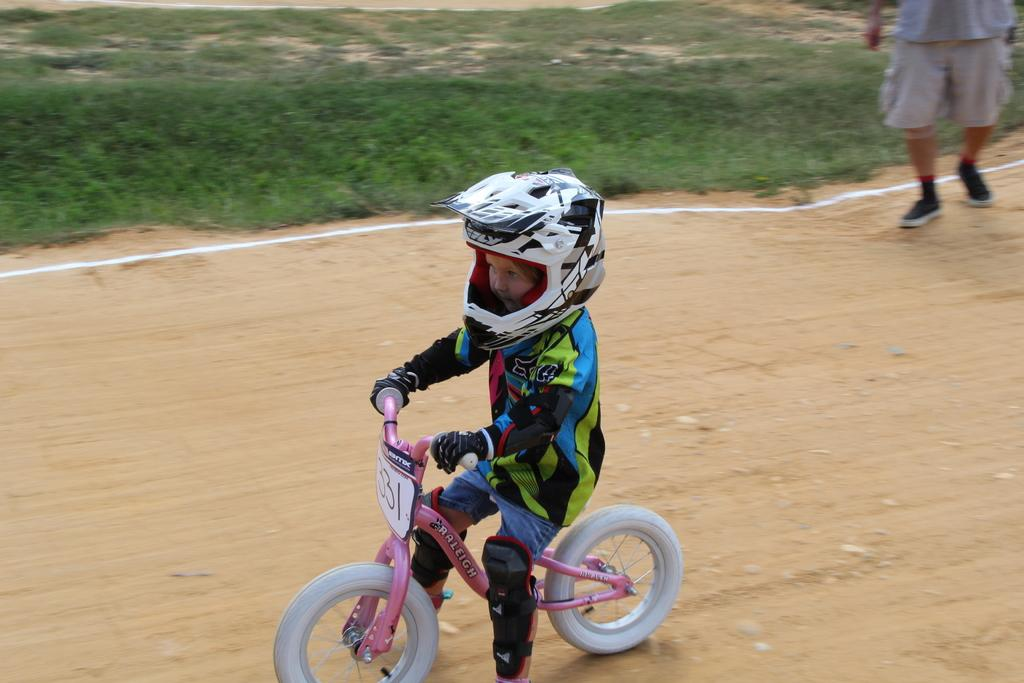Who is the main subject in the image? The main subject in the image is a child. What is the child doing in the image? The child is sitting on a bicycle. Is the child wearing any safety gear in the image? Yes, the child is wearing a helmet in the image. Where is the child located in the image? The child is on the road in the image. Can you describe the person on the ground in the image? There is a person on the ground in the image, but their actions or role cannot be determined from the provided facts. What type of authority figure is present in the image? There is no authority figure present in the image. How does the child receive support while sitting on the bicycle? The provided facts do not mention any support for the child while sitting on the bicycle. 